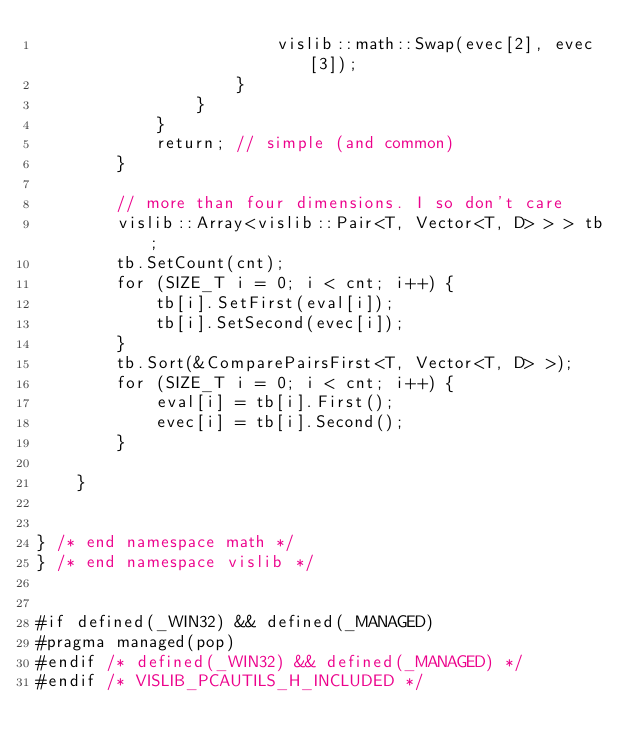Convert code to text. <code><loc_0><loc_0><loc_500><loc_500><_C_>                        vislib::math::Swap(evec[2], evec[3]);
                    }
                }
            }
            return; // simple (and common)
        }

        // more than four dimensions. I so don't care
        vislib::Array<vislib::Pair<T, Vector<T, D> > > tb;
        tb.SetCount(cnt);
        for (SIZE_T i = 0; i < cnt; i++) {
            tb[i].SetFirst(eval[i]);
            tb[i].SetSecond(evec[i]);
        }
        tb.Sort(&ComparePairsFirst<T, Vector<T, D> >);
        for (SIZE_T i = 0; i < cnt; i++) {
            eval[i] = tb[i].First();
            evec[i] = tb[i].Second();
        }

    }


} /* end namespace math */
} /* end namespace vislib */


#if defined(_WIN32) && defined(_MANAGED)
#pragma managed(pop)
#endif /* defined(_WIN32) && defined(_MANAGED) */
#endif /* VISLIB_PCAUTILS_H_INCLUDED */
</code> 